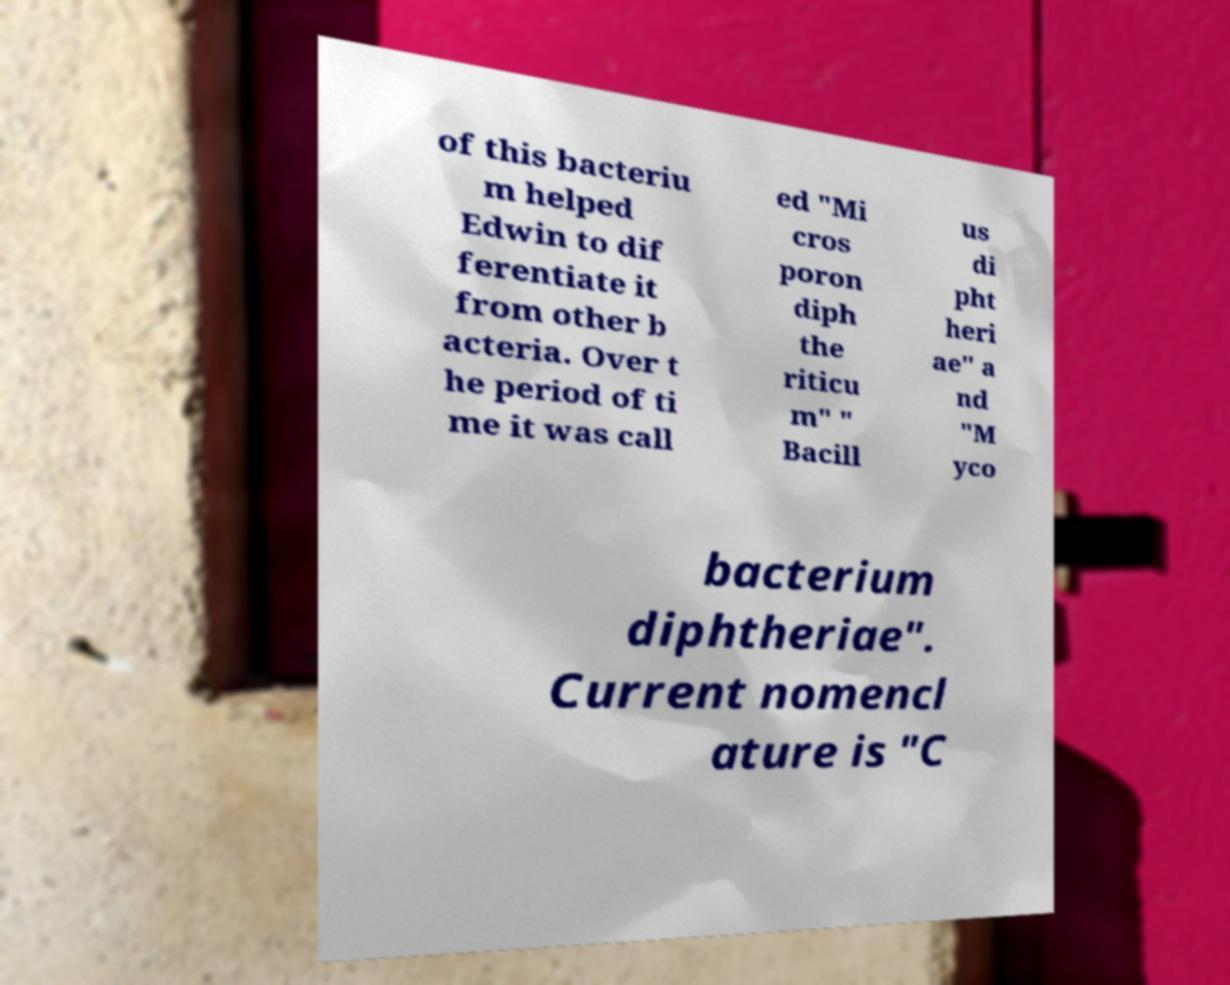For documentation purposes, I need the text within this image transcribed. Could you provide that? of this bacteriu m helped Edwin to dif ferentiate it from other b acteria. Over t he period of ti me it was call ed "Mi cros poron diph the riticu m" " Bacill us di pht heri ae" a nd "M yco bacterium diphtheriae". Current nomencl ature is "C 